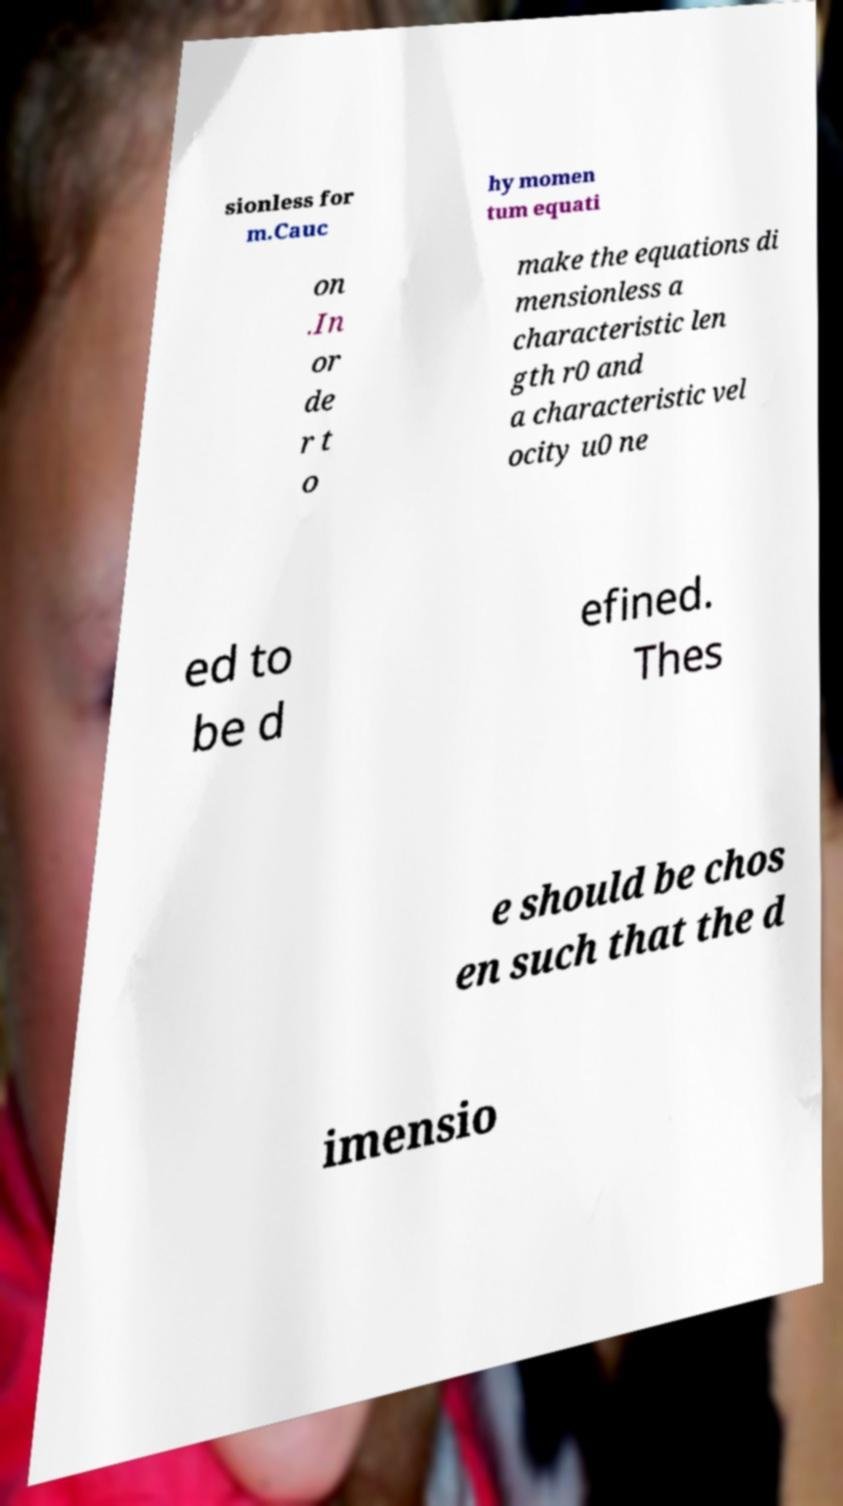Can you read and provide the text displayed in the image?This photo seems to have some interesting text. Can you extract and type it out for me? sionless for m.Cauc hy momen tum equati on .In or de r t o make the equations di mensionless a characteristic len gth r0 and a characteristic vel ocity u0 ne ed to be d efined. Thes e should be chos en such that the d imensio 